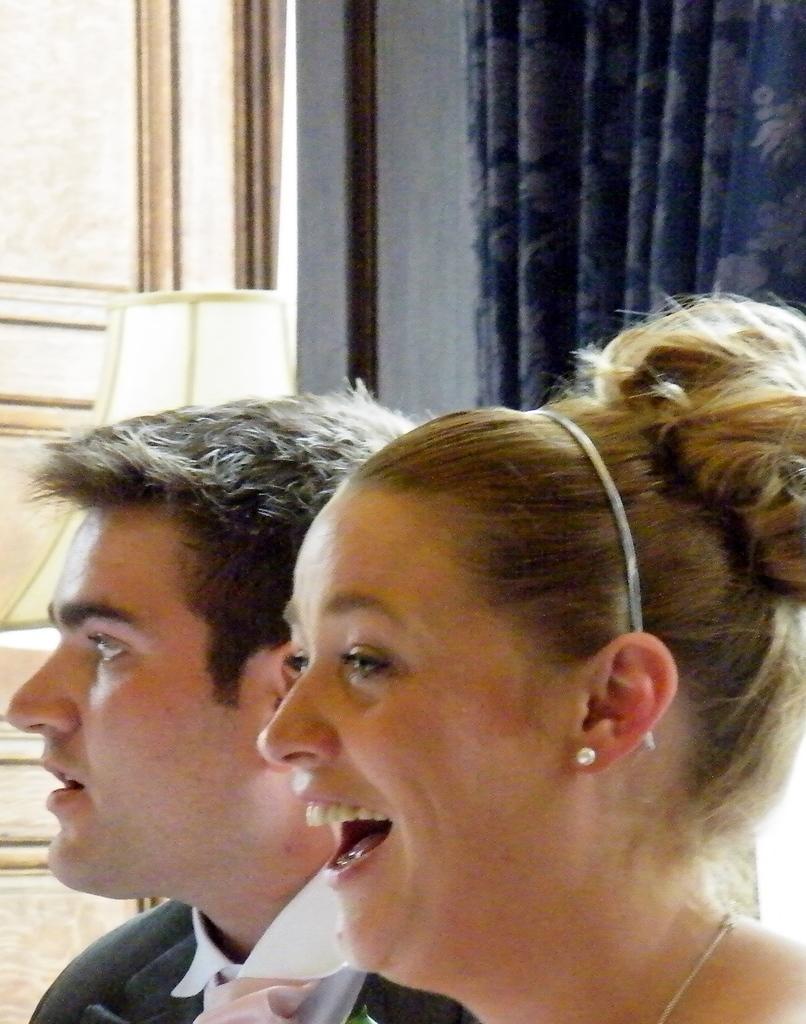In one or two sentences, can you explain what this image depicts? In this picture I see a man and a woman in front and I see that this woman is smiling. In the background I see a cloth which is of white in color. 